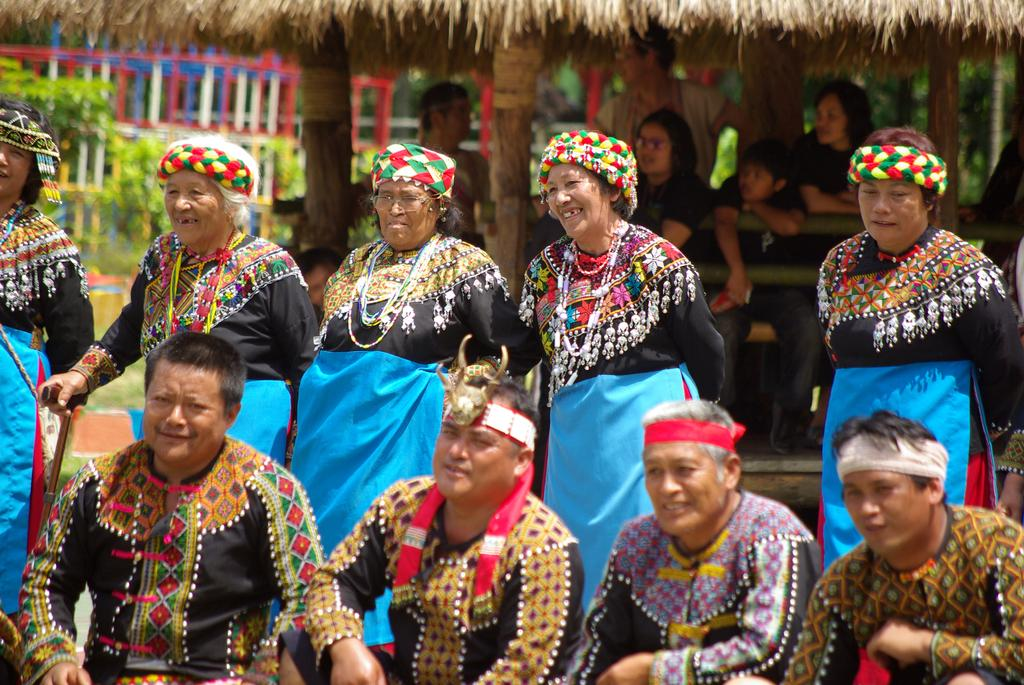How many men are sitting in the image? There are four men sitting in the image. How many women are standing in the image? There are five women standing in the image. What can be seen in the background of the image? There is a hut in the background of the image. Are there any people inside the hut? Yes, there are people sitting inside the hut. Can you see any drains in the image? There are no drains visible in the image. Is there a cobweb present in the image? There is no cobweb present in the image. 